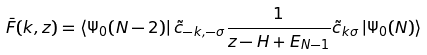Convert formula to latex. <formula><loc_0><loc_0><loc_500><loc_500>\bar { F } ( k , z ) = \left \langle \Psi _ { 0 } ( N - 2 ) \right | \tilde { c } _ { - k , - \sigma } \frac { 1 } { z - H + E _ { N - 1 } } \tilde { c } _ { k \sigma } \left | \Psi _ { 0 } ( N ) \right \rangle</formula> 